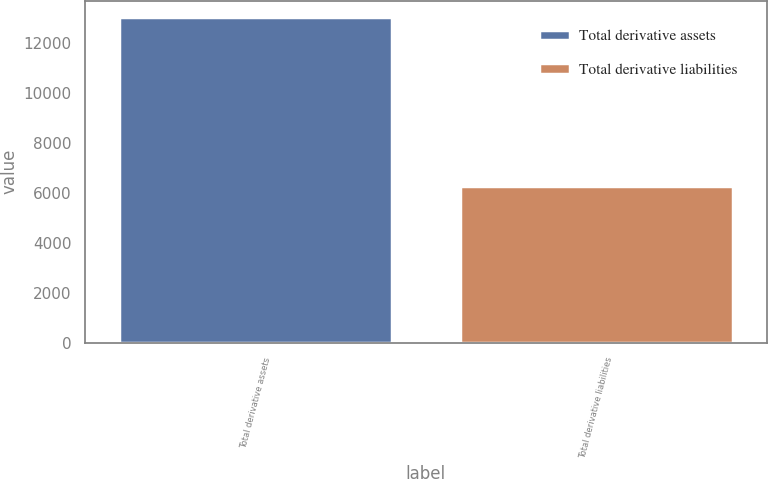<chart> <loc_0><loc_0><loc_500><loc_500><bar_chart><fcel>Total derivative assets<fcel>Total derivative liabilities<nl><fcel>13022<fcel>6281<nl></chart> 